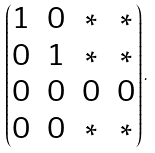Convert formula to latex. <formula><loc_0><loc_0><loc_500><loc_500>\begin{pmatrix} 1 & 0 & * & * \\ 0 & 1 & * & * \\ 0 & 0 & 0 & 0 \\ 0 & 0 & * & * \\ \end{pmatrix} .</formula> 